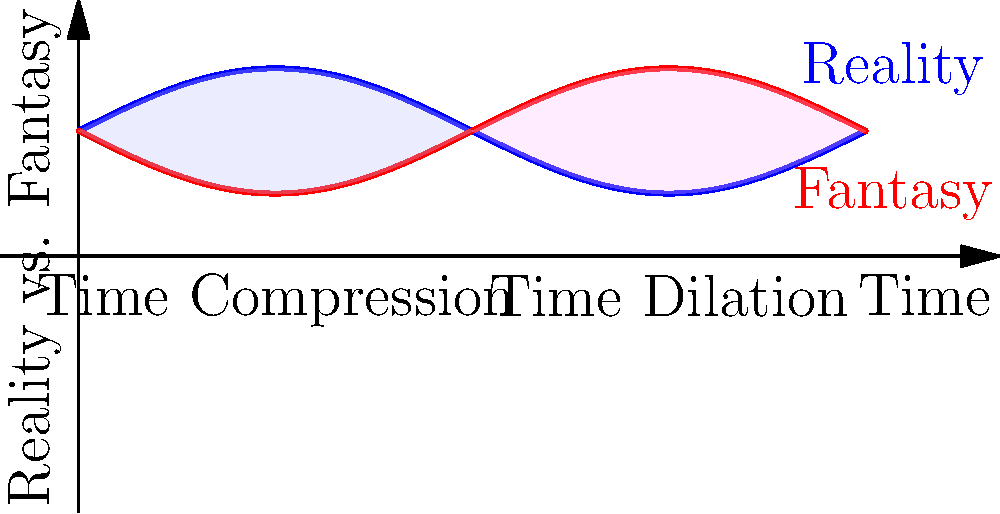Analyze the graph depicting the interplay between reality and fantasy in a novel's timeline. How does the visual representation illustrate the concept of time distortion in fantasy-realism hybrid storytelling, and what narrative techniques might be employed to achieve these effects? 1. Graph Analysis:
   - The x-axis represents time, while the y-axis represents the spectrum between reality and fantasy.
   - Two sinusoidal curves are shown: blue for reality and red for fantasy.

2. Time Distortion:
   - Where the curves intersect, reality and fantasy blend.
   - The shaded areas represent periods of time distortion:
     a) Pale blue area: Time compression (first half of the timeline)
     b) Pink area: Time dilation (second half of the timeline)

3. Narrative Implications:
   - Time Compression: Events occur rapidly, condensing a large amount of information or action into a short narrative space.
   - Time Dilation: Time seems to stretch, allowing for detailed exploration of moments or experiences.

4. Storytelling Techniques:
   a) For Time Compression:
      - Montage sequences
      - Summarized passages
      - Rapid dialogue or action scenes
   b) For Time Dilation:
      - Detailed descriptions
      - Internal monologues
      - Slow-motion narrative techniques

5. Reality-Fantasy Interplay:
   - The oscillation between reality and fantasy curves suggests a constant shift in narrative focus.
   - Points where curves are far apart indicate clear distinction between real and fantastical elements.
   - Intersections represent moments where the boundary between reality and fantasy blurs.

6. Narrative Structure:
   - The cyclic nature of the curves implies a recurring pattern in the story's structure.
   - This could represent alternating chapters, scenes, or perspectives between reality-based and fantasy-based narratives.

7. Character Experience:
   - The graph could represent a character's perception of time and reality throughout the story.
   - Peaks and troughs might correlate with emotional highs and lows or moments of clarity versus confusion.
Answer: Time compression and dilation, represented by shaded areas, are achieved through varied pacing techniques (e.g., montages, detailed descriptions) that blend reality and fantasy elements, creating a cyclical narrative structure that reflects characters' perceptions of time and reality. 